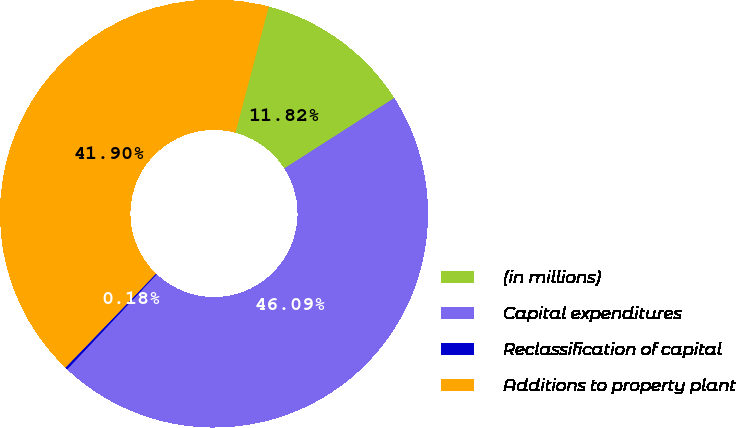Convert chart. <chart><loc_0><loc_0><loc_500><loc_500><pie_chart><fcel>(in millions)<fcel>Capital expenditures<fcel>Reclassification of capital<fcel>Additions to property plant<nl><fcel>11.82%<fcel>46.09%<fcel>0.18%<fcel>41.9%<nl></chart> 